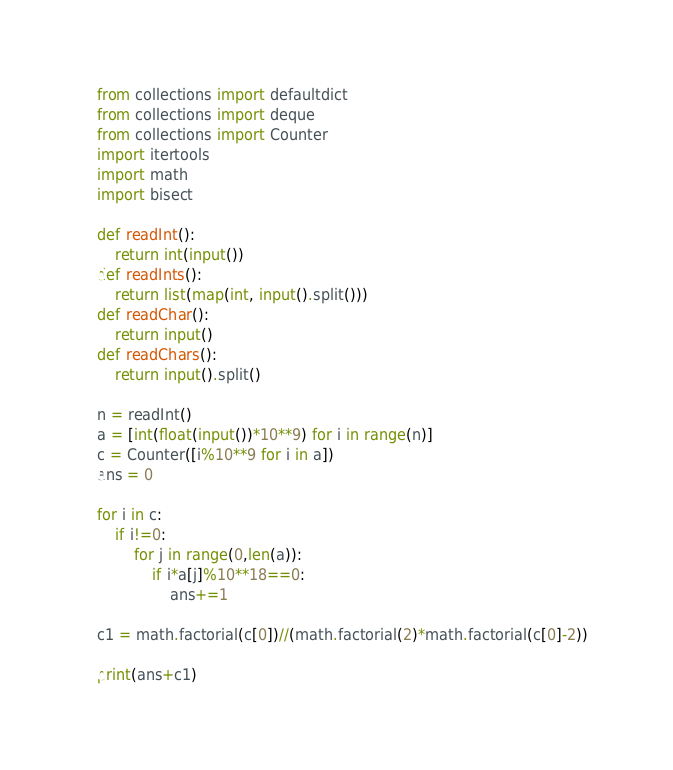Convert code to text. <code><loc_0><loc_0><loc_500><loc_500><_Python_>from collections import defaultdict
from collections import deque
from collections import Counter
import itertools
import math
import bisect

def readInt():
	return int(input())
def readInts():
	return list(map(int, input().split()))
def readChar():
	return input()
def readChars():
	return input().split()

n = readInt()
a = [int(float(input())*10**9) for i in range(n)]
c = Counter([i%10**9 for i in a])
ans = 0

for i in c:
	if i!=0:
		for j in range(0,len(a)):
			if i*a[j]%10**18==0:
				ans+=1

c1 = math.factorial(c[0])//(math.factorial(2)*math.factorial(c[0]-2))

print(ans+c1)</code> 